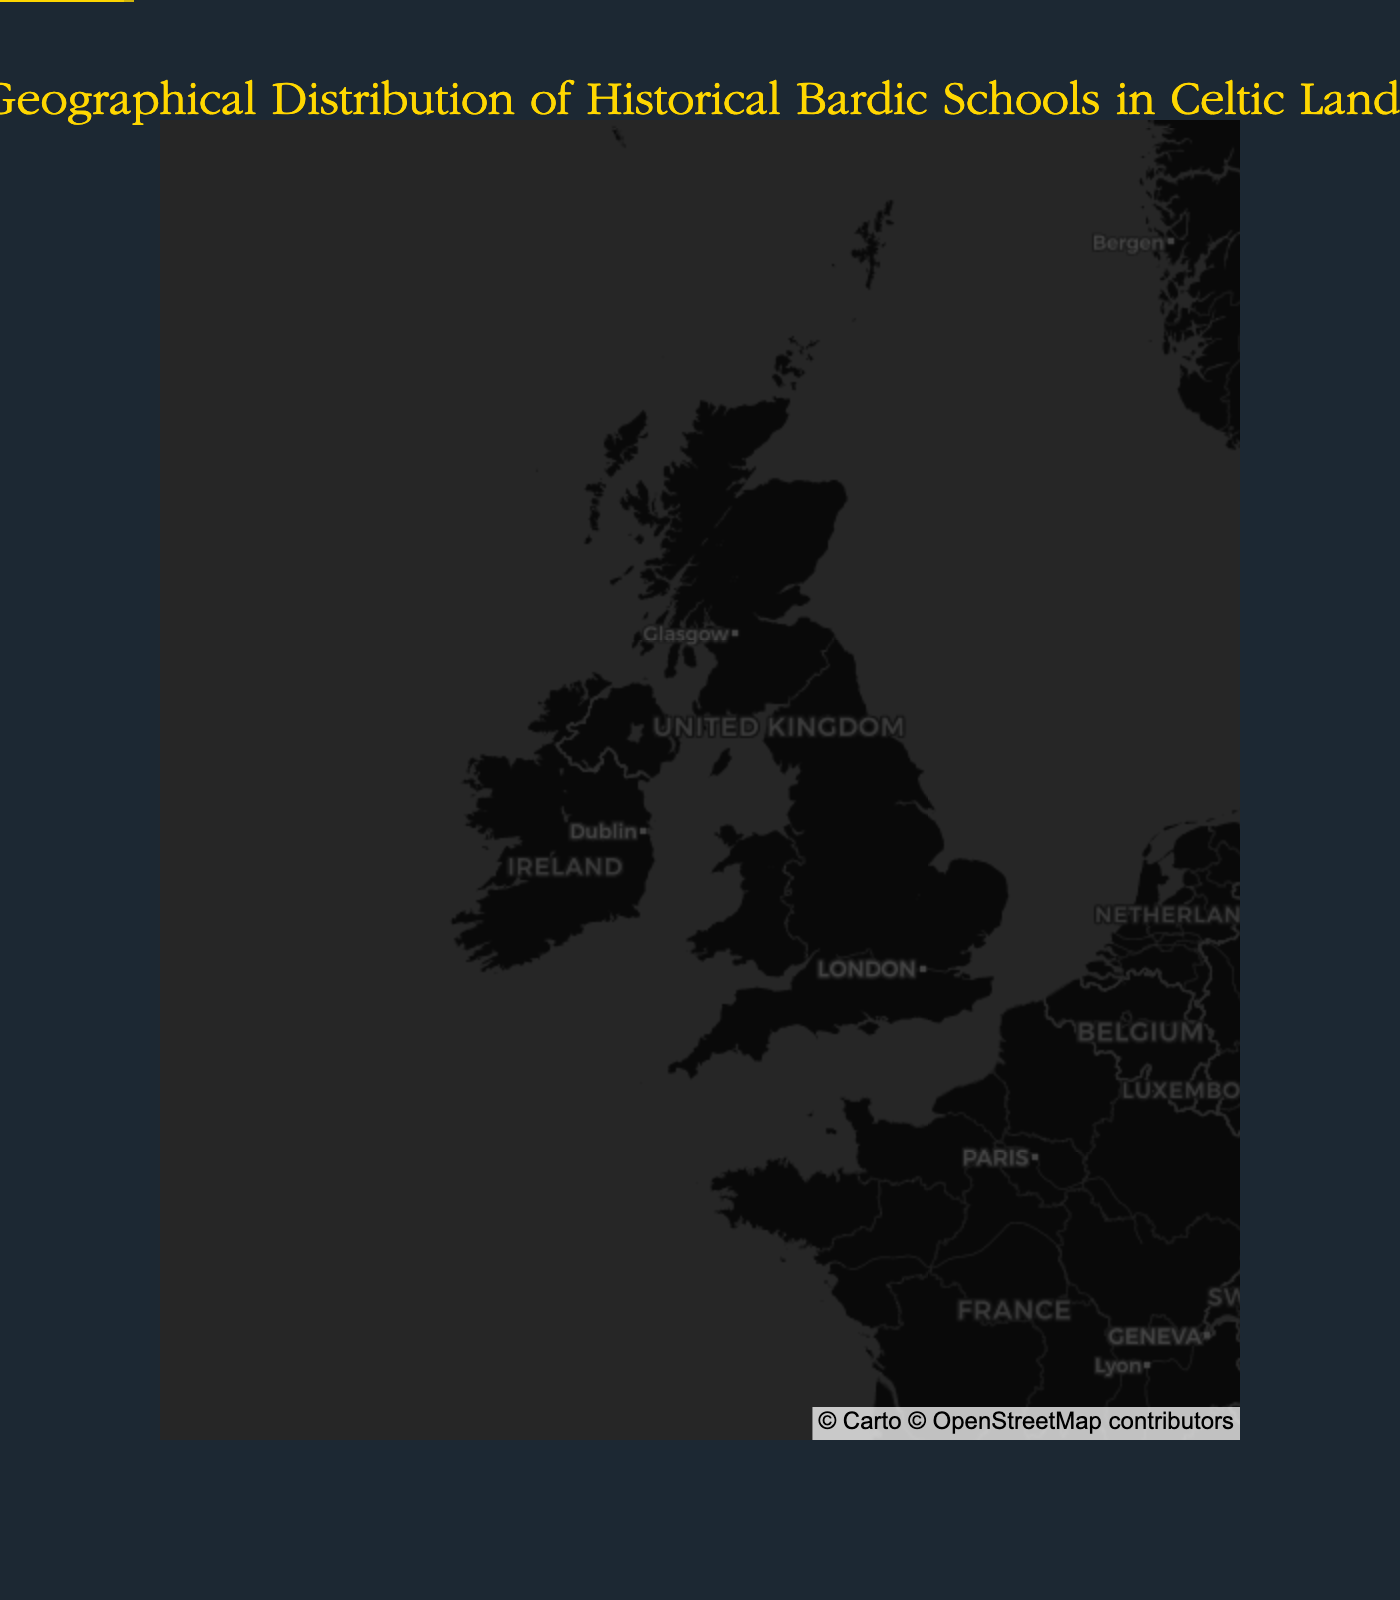what is the title of the figure? The title is located at the top of the figure. It is displayed in a larger font to stand out.
Answer: Geographical Distribution of Historical Bardic Schools in Celtic Lands How many bardic schools are shown on the map? Count each of the markers, as each represents a bardic school.
Answer: 10 Which school was founded the earliest? Identify the founding years of all the schools from the hover data and determine the oldest year.
Answer: Ard Mhacha Bardic Circle (1089) What is the specialization of the school located in Sligo? Locate the marker in Sligo and refer to the hover data for its specialization.
Answer: Poetry and Storytelling Which location has more than one bardic school? Since each city or town on the map has a unique pin, examine all to notice there are no overlapping markers.
Answer: None On average, what is the founding year of the displayed bardic schools? Sum the founding years of all the schools and divide by the number of schools: (1089 + 1098 + 1123 + 1132 + 1143 + 1156 + 1167 + 1176 + 1189 + 1201) / 10 = 1147.4.
Answer: 1147 Which two schools are the furthest apart geographically? Identify the markers for Inverness and Carmarthen, which are at the northernmost and southernmost points respectively.
Answer: Highland Bardic Academy and Canolfan Taliesin How many bardic schools specialize in poetry? Review the hover data for each marker, counting any school with specialization including poetry.
Answer: 4 What is the common specialization among schools located in Wales? Identify schools in Aberystwyth and Caernarfon from their names and hover data, noting they both focus on Welsh traditions/poetry.
Answer: Welsh traditions and poetry Which school focuses on Scottish bagpipes and ballads, and where is it located? Find the marker with specialization indicated in the hover data, specifying Scottish bagpipes and ballads.
Answer: Royal School of Celtic Music in Edinburgh 